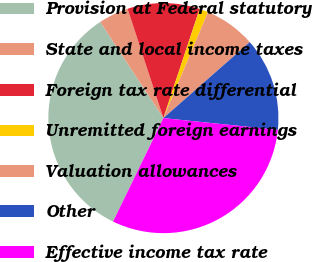Convert chart to OTSL. <chart><loc_0><loc_0><loc_500><loc_500><pie_chart><fcel>Provision at Federal statutory<fcel>State and local income taxes<fcel>Foreign tax rate differential<fcel>Unremitted foreign earnings<fcel>Valuation allowances<fcel>Other<fcel>Effective income tax rate<nl><fcel>33.55%<fcel>4.21%<fcel>10.14%<fcel>1.24%<fcel>7.18%<fcel>13.11%<fcel>30.58%<nl></chart> 